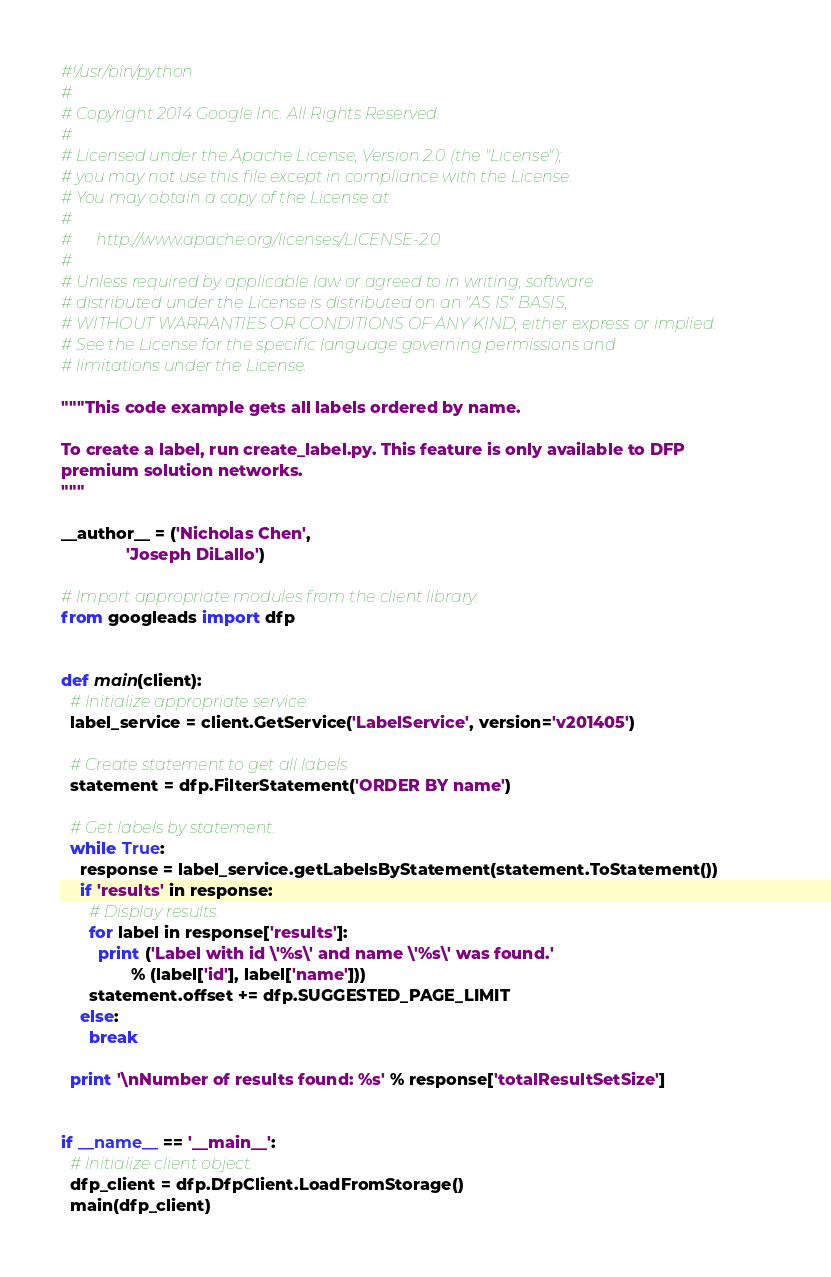<code> <loc_0><loc_0><loc_500><loc_500><_Python_>#!/usr/bin/python
#
# Copyright 2014 Google Inc. All Rights Reserved.
#
# Licensed under the Apache License, Version 2.0 (the "License");
# you may not use this file except in compliance with the License.
# You may obtain a copy of the License at
#
#      http://www.apache.org/licenses/LICENSE-2.0
#
# Unless required by applicable law or agreed to in writing, software
# distributed under the License is distributed on an "AS IS" BASIS,
# WITHOUT WARRANTIES OR CONDITIONS OF ANY KIND, either express or implied.
# See the License for the specific language governing permissions and
# limitations under the License.

"""This code example gets all labels ordered by name.

To create a label, run create_label.py. This feature is only available to DFP
premium solution networks.
"""

__author__ = ('Nicholas Chen',
              'Joseph DiLallo')

# Import appropriate modules from the client library.
from googleads import dfp


def main(client):
  # Initialize appropriate service.
  label_service = client.GetService('LabelService', version='v201405')

  # Create statement to get all labels
  statement = dfp.FilterStatement('ORDER BY name')

  # Get labels by statement.
  while True:
    response = label_service.getLabelsByStatement(statement.ToStatement())
    if 'results' in response:
      # Display results.
      for label in response['results']:
        print ('Label with id \'%s\' and name \'%s\' was found.'
               % (label['id'], label['name']))
      statement.offset += dfp.SUGGESTED_PAGE_LIMIT
    else:
      break

  print '\nNumber of results found: %s' % response['totalResultSetSize']


if __name__ == '__main__':
  # Initialize client object.
  dfp_client = dfp.DfpClient.LoadFromStorage()
  main(dfp_client)
</code> 